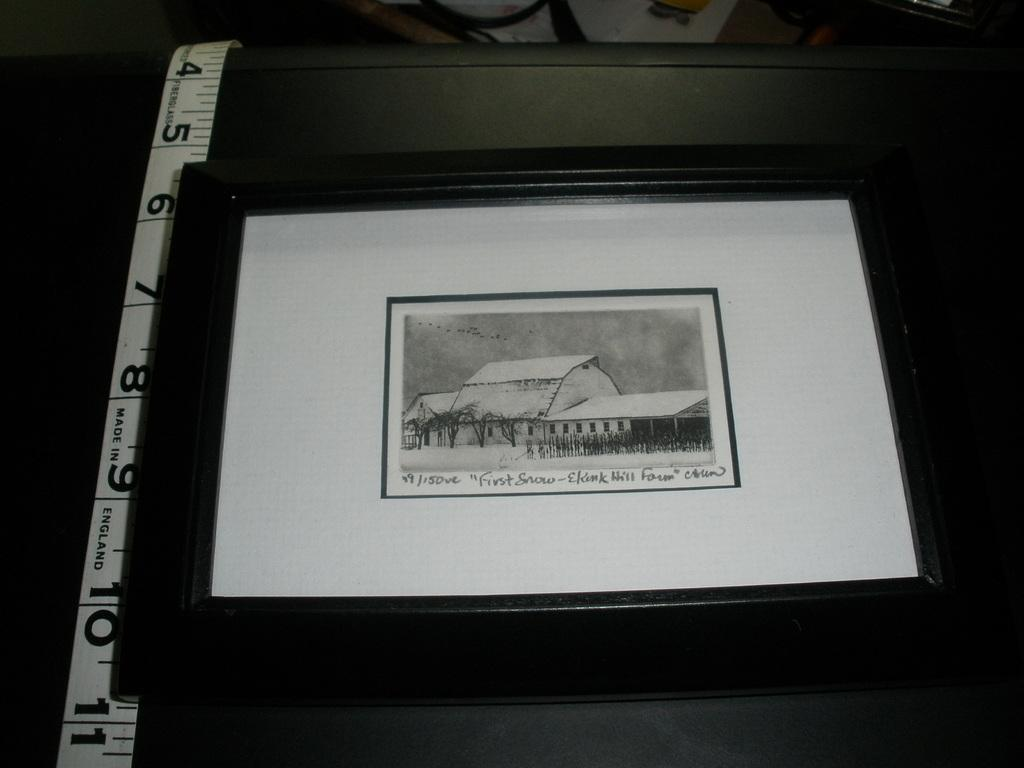<image>
Give a short and clear explanation of the subsequent image. A very small black and white picture named "First Snow" 